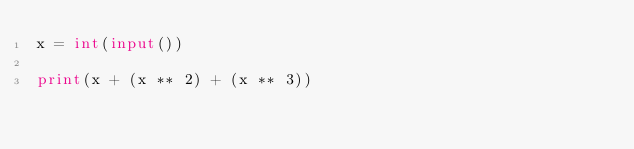Convert code to text. <code><loc_0><loc_0><loc_500><loc_500><_Python_>x = int(input())

print(x + (x ** 2) + (x ** 3))</code> 